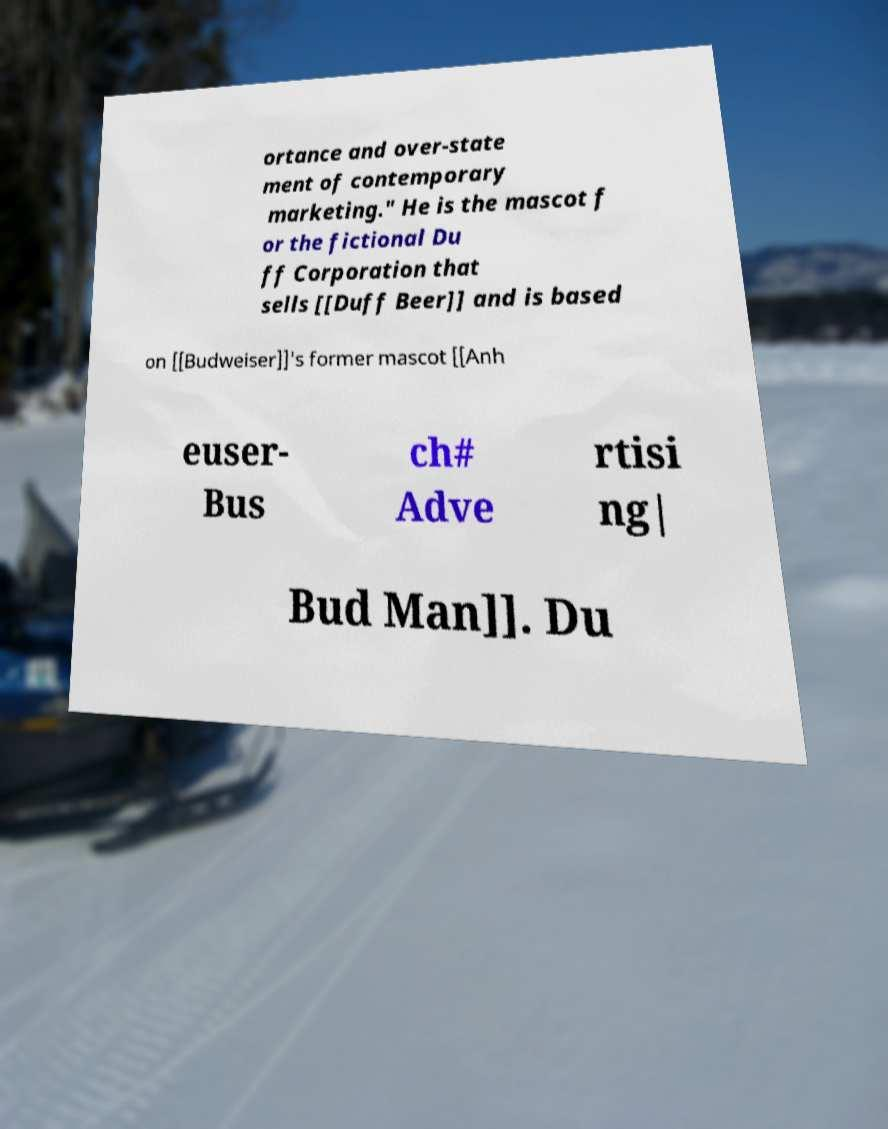Can you read and provide the text displayed in the image?This photo seems to have some interesting text. Can you extract and type it out for me? ortance and over-state ment of contemporary marketing." He is the mascot f or the fictional Du ff Corporation that sells [[Duff Beer]] and is based on [[Budweiser]]'s former mascot [[Anh euser- Bus ch# Adve rtisi ng| Bud Man]]. Du 